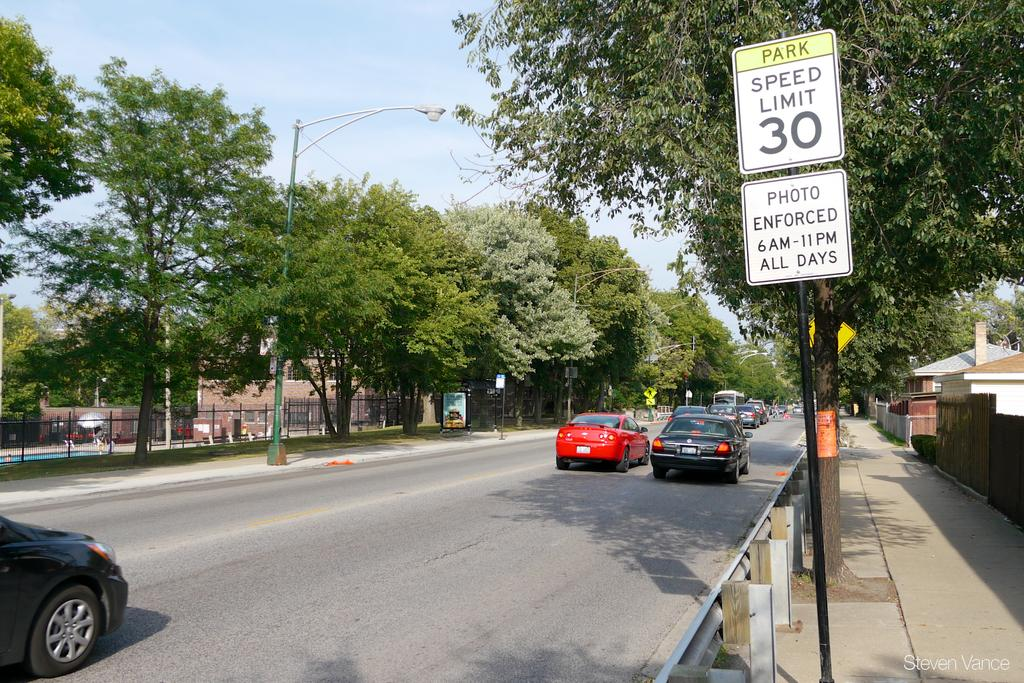Provide a one-sentence caption for the provided image. Cars travelling down a street with a 30 mile per hour speed limit. 